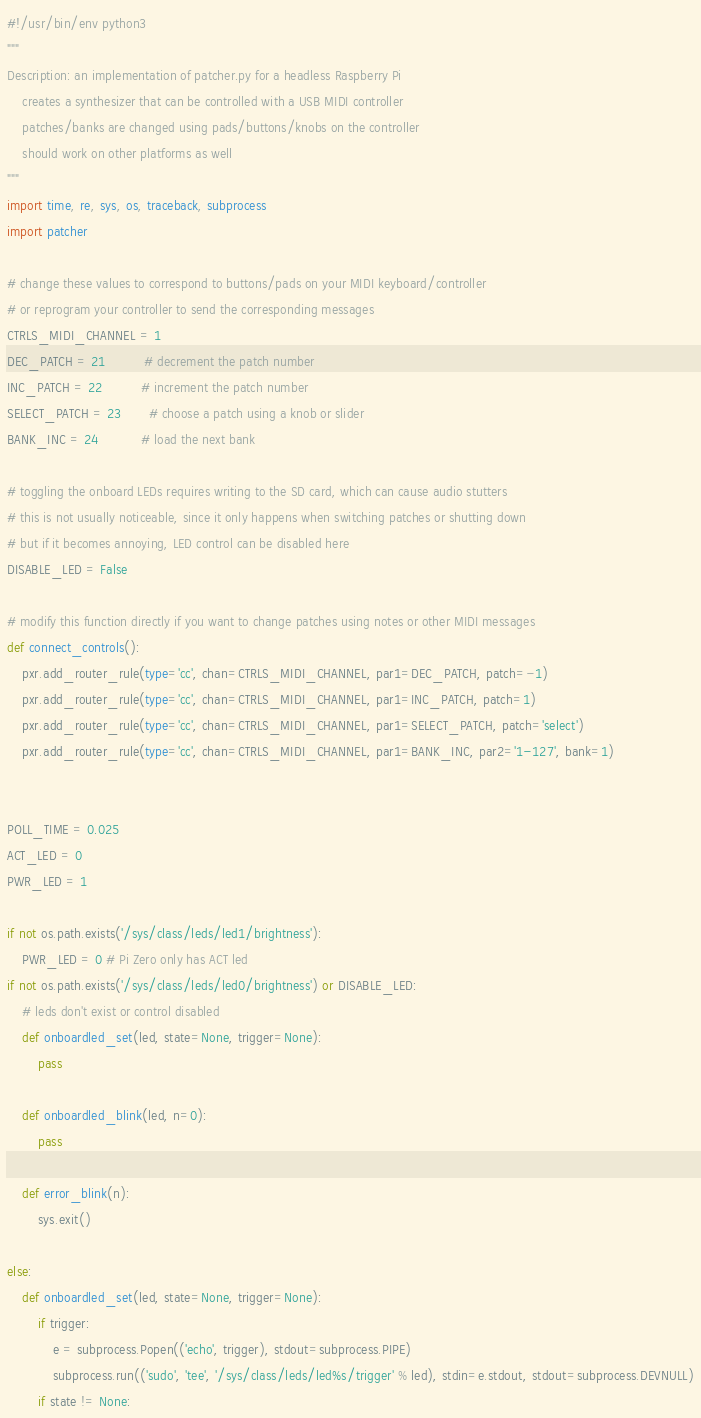Convert code to text. <code><loc_0><loc_0><loc_500><loc_500><_Python_>#!/usr/bin/env python3
"""
Description: an implementation of patcher.py for a headless Raspberry Pi
    creates a synthesizer that can be controlled with a USB MIDI controller
    patches/banks are changed using pads/buttons/knobs on the controller
    should work on other platforms as well
"""
import time, re, sys, os, traceback, subprocess
import patcher

# change these values to correspond to buttons/pads on your MIDI keyboard/controller
# or reprogram your controller to send the corresponding messages
CTRLS_MIDI_CHANNEL = 1
DEC_PATCH = 21          # decrement the patch number
INC_PATCH = 22          # increment the patch number
SELECT_PATCH = 23       # choose a patch using a knob or slider
BANK_INC = 24           # load the next bank

# toggling the onboard LEDs requires writing to the SD card, which can cause audio stutters
# this is not usually noticeable, since it only happens when switching patches or shutting down
# but if it becomes annoying, LED control can be disabled here
DISABLE_LED = False

# modify this function directly if you want to change patches using notes or other MIDI messages
def connect_controls():
    pxr.add_router_rule(type='cc', chan=CTRLS_MIDI_CHANNEL, par1=DEC_PATCH, patch=-1)
    pxr.add_router_rule(type='cc', chan=CTRLS_MIDI_CHANNEL, par1=INC_PATCH, patch=1)
    pxr.add_router_rule(type='cc', chan=CTRLS_MIDI_CHANNEL, par1=SELECT_PATCH, patch='select')
    pxr.add_router_rule(type='cc', chan=CTRLS_MIDI_CHANNEL, par1=BANK_INC, par2='1-127', bank=1)


POLL_TIME = 0.025
ACT_LED = 0
PWR_LED = 1

if not os.path.exists('/sys/class/leds/led1/brightness'):
    PWR_LED = 0 # Pi Zero only has ACT led
if not os.path.exists('/sys/class/leds/led0/brightness') or DISABLE_LED:
    # leds don't exist or control disabled
    def onboardled_set(led, state=None, trigger=None):
        pass
        
    def onboardled_blink(led, n=0):
        pass
        
    def error_blink(n):
        sys.exit()
        
else:
    def onboardled_set(led, state=None, trigger=None):
        if trigger:
            e = subprocess.Popen(('echo', trigger), stdout=subprocess.PIPE)
            subprocess.run(('sudo', 'tee', '/sys/class/leds/led%s/trigger' % led), stdin=e.stdout, stdout=subprocess.DEVNULL)
        if state != None:</code> 